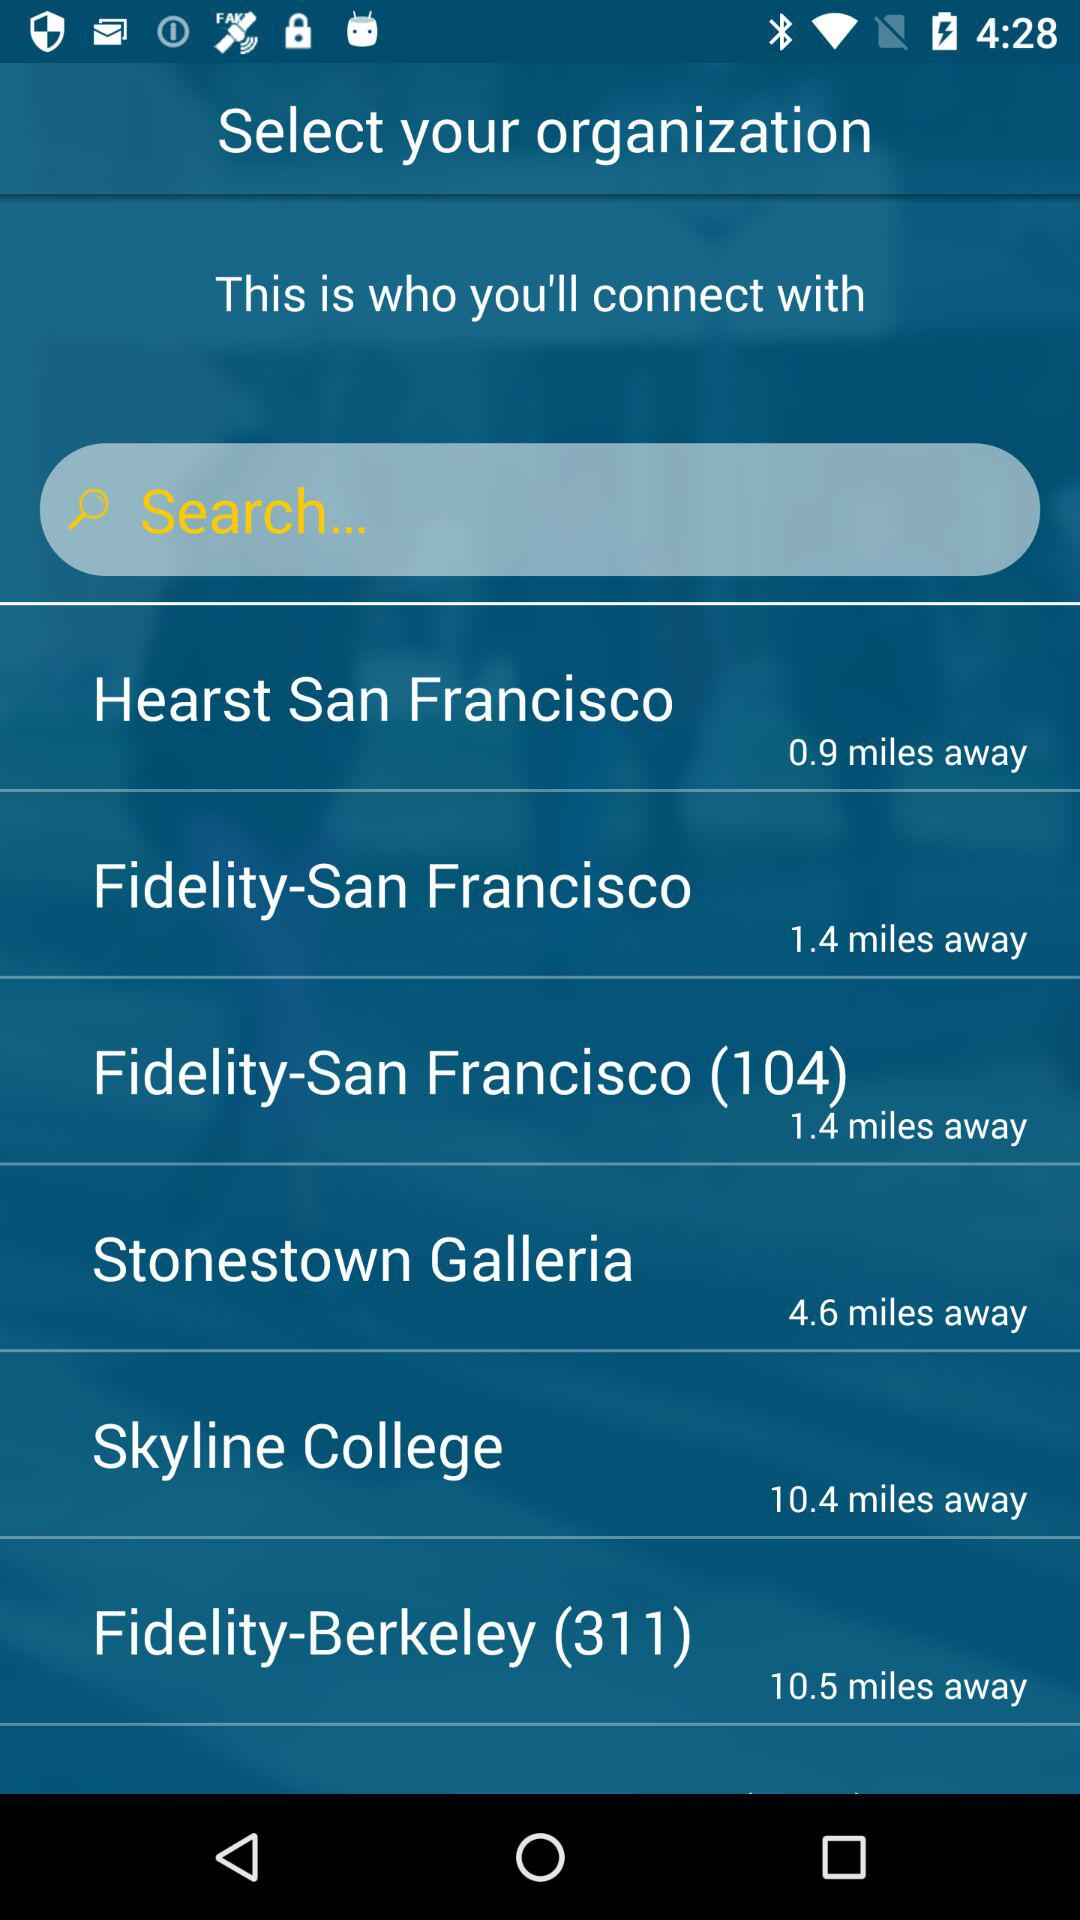How far away is Hearst Skyline College?
When the provided information is insufficient, respond with <no answer>. <no answer> 